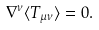Convert formula to latex. <formula><loc_0><loc_0><loc_500><loc_500>\nabla ^ { \nu } \langle T _ { \mu \nu } \rangle = 0 .</formula> 